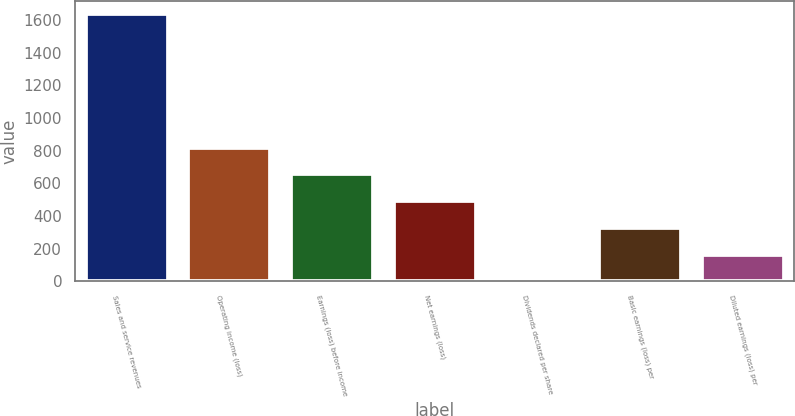Convert chart. <chart><loc_0><loc_0><loc_500><loc_500><bar_chart><fcel>Sales and service revenues<fcel>Operating income (loss)<fcel>Earnings (loss) before income<fcel>Net earnings (loss)<fcel>Dividends declared per share<fcel>Basic earnings (loss) per<fcel>Diluted earnings (loss) per<nl><fcel>1637<fcel>818.55<fcel>654.86<fcel>491.17<fcel>0.1<fcel>327.48<fcel>163.79<nl></chart> 